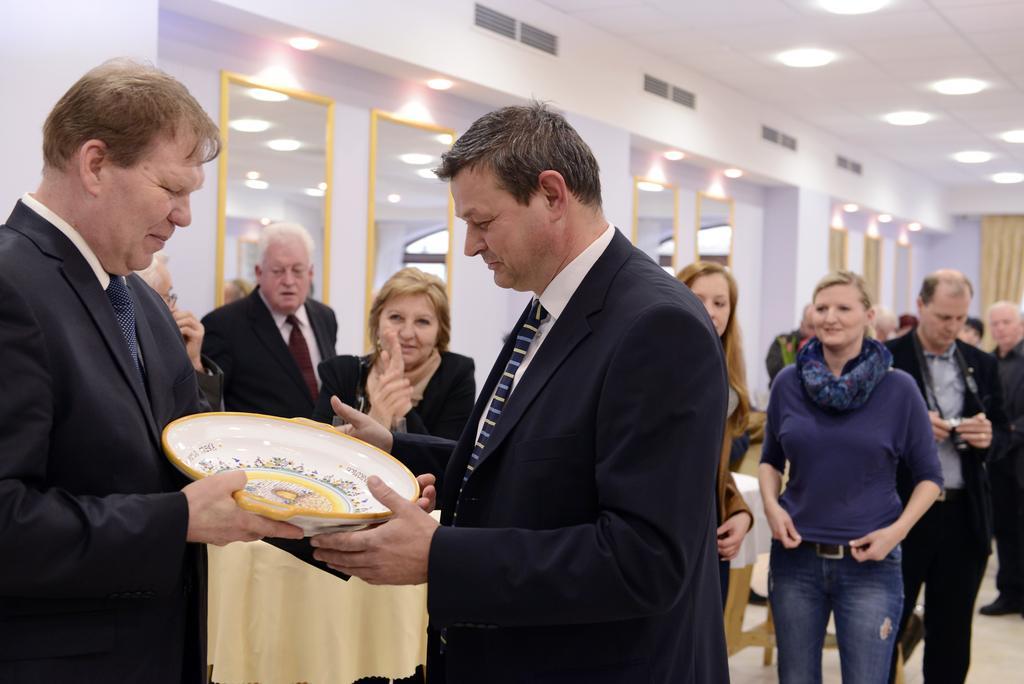Please provide a concise description of this image. In the image I can see two people wearing suits and holding bowl like thing and behind there are some other people, mirrors and some lights to the roof. 